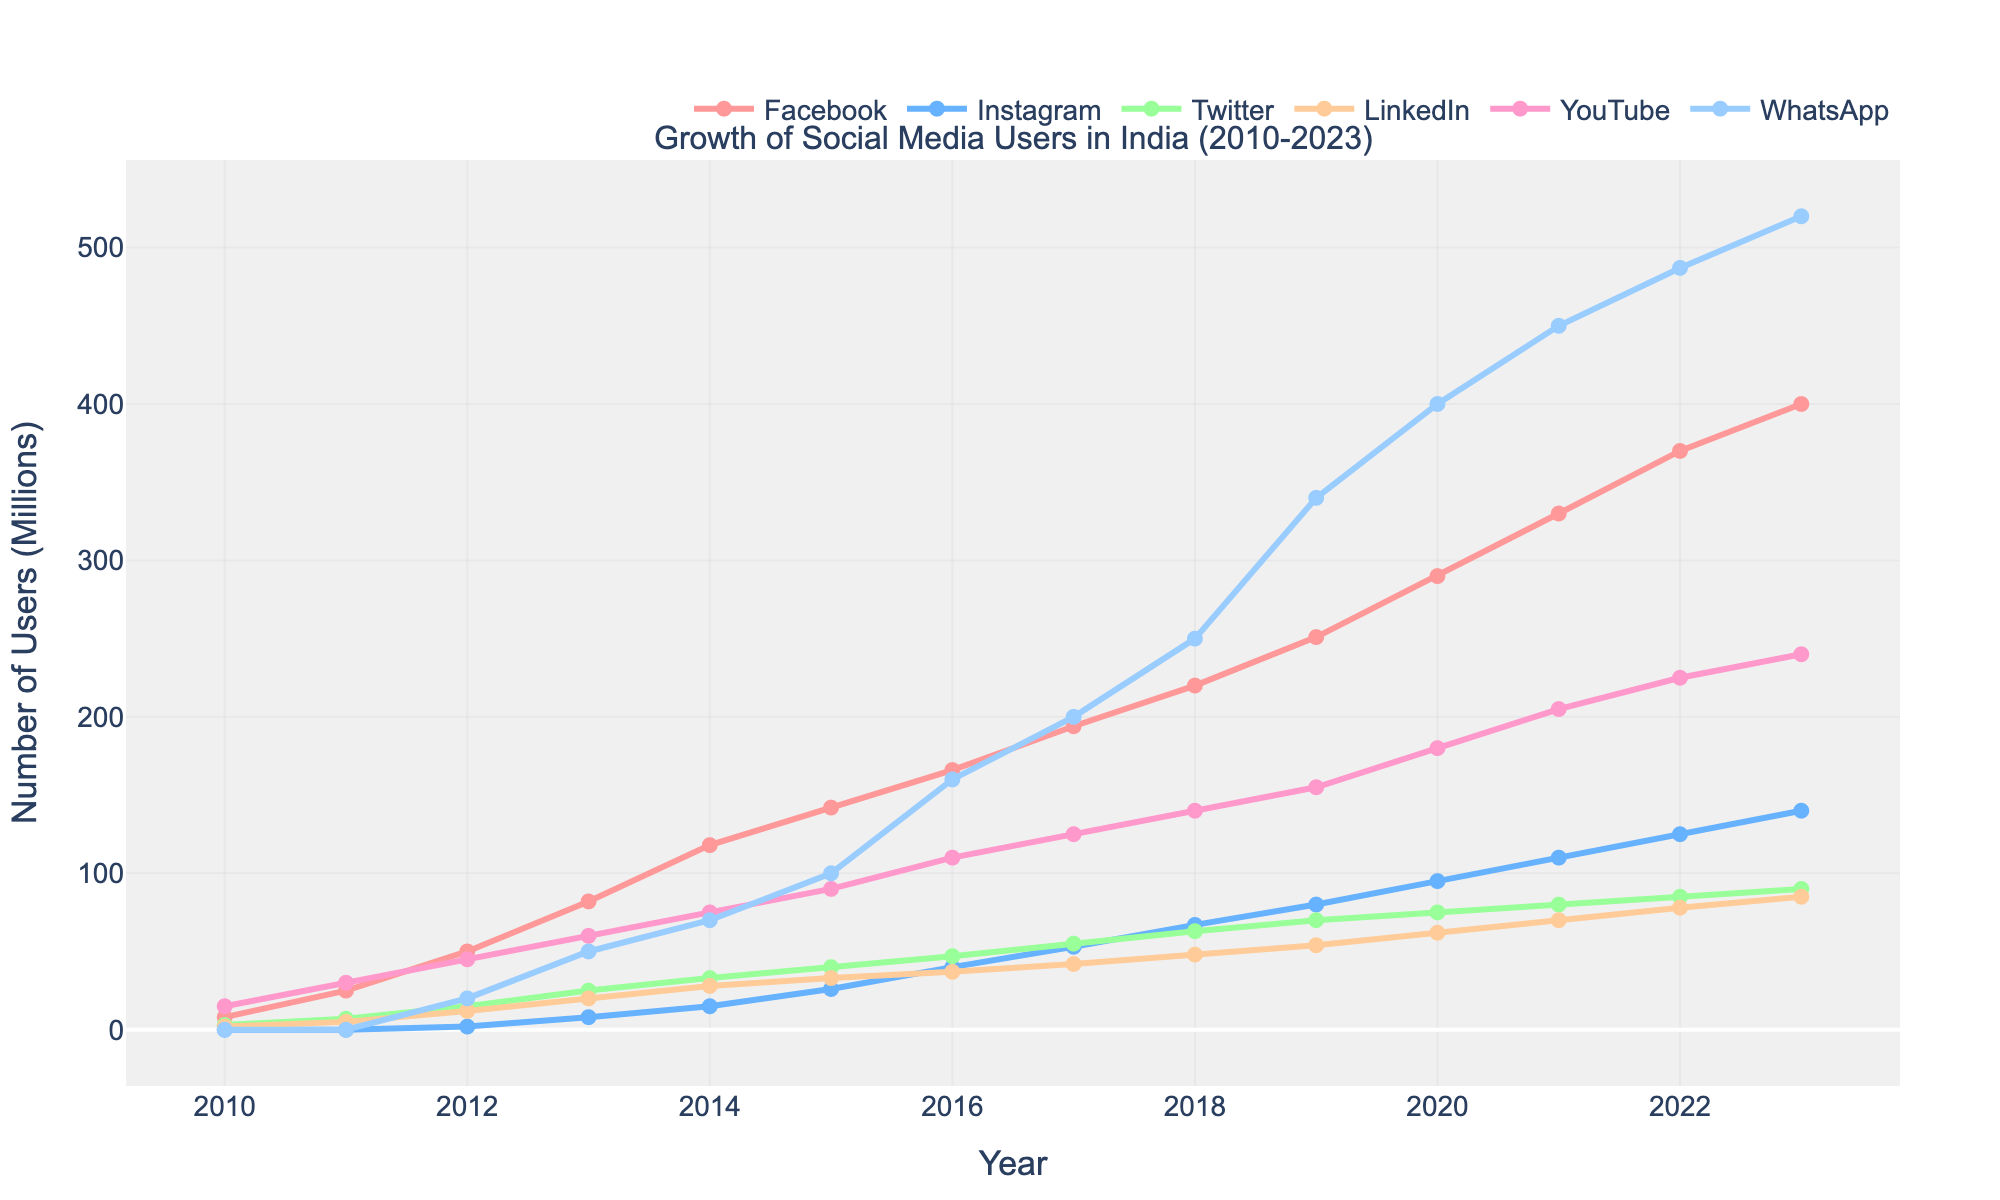What's the platform with the highest number of users in 2023? By examining the end points of 2023 on the graph, we see that WhatsApp has the highest value.
Answer: WhatsApp Which year did Instagram first surpass 50 million users? Trace the line representing Instagram and find when it crosses the 50 million mark. This occurs between 2016 and 2017.
Answer: 2017 By how many millions did Facebook users increase from 2016 to 2017? Identify the Facebook values for 2016 (166 million) and 2017 (194 million). Calculate the difference: 194 - 166.
Answer: 28 million What is the combined number of users for Twitter and LinkedIn in 2014? For 2014, add the values of Twitter (33 million) and LinkedIn (28 million).
Answer: 61 million Which platform saw the greatest increase in users between 2010 and 2023? Compare the starting and ending values for each platform. WhatsApp grew from 0 in 2010 to 520 million in 2023, the largest increase.
Answer: WhatsApp What is the color of the YouTube line on the graph? Refer to the visual representation and the color used for the YouTube line.
Answer: Red Which year did YouTube reach 150 million users? Follow the YouTube line to find the point where it hits 150 million. This occurs between 2018 and 2019.
Answer: 2019 Comparing 2010 to 2013, which platform had the fastest growth rate? Calculate the growth for each platform (2013 value minus 2010 value). Facebook grew by 74, Instagram by 8, Twitter by 22, LinkedIn by 18, YouTube by 45, and WhatsApp by 50.
Answer: WhatsApp By what percentage did the number of Instagram users increase from 2019 to 2020? Find 2019 and 2020 values for Instagram (80 million and 95 million, respectively). Calculate the percentage increase: ((95-80)/80)*100%.
Answer: 18.75% In which year did LinkedIn surpass 20 million users, and by how much? Locate when LinkedIn crosses the 20 million mark, which is in 2013. The exact value in 2013 is 20 million.
Answer: 2013, 0 million 